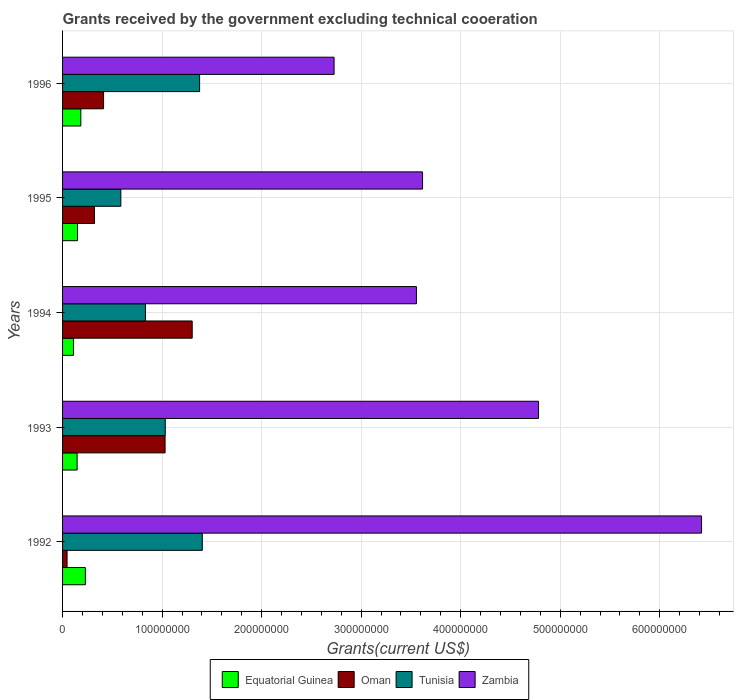Are the number of bars per tick equal to the number of legend labels?
Your answer should be compact. Yes. How many bars are there on the 4th tick from the top?
Offer a very short reply. 4. In how many cases, is the number of bars for a given year not equal to the number of legend labels?
Ensure brevity in your answer.  0. What is the total grants received by the government in Tunisia in 1992?
Your answer should be compact. 1.40e+08. Across all years, what is the maximum total grants received by the government in Oman?
Your answer should be very brief. 1.30e+08. Across all years, what is the minimum total grants received by the government in Tunisia?
Your response must be concise. 5.85e+07. What is the total total grants received by the government in Oman in the graph?
Provide a short and direct response. 3.11e+08. What is the difference between the total grants received by the government in Oman in 1992 and that in 1993?
Your response must be concise. -9.85e+07. What is the difference between the total grants received by the government in Oman in 1992 and the total grants received by the government in Zambia in 1996?
Give a very brief answer. -2.68e+08. What is the average total grants received by the government in Tunisia per year?
Give a very brief answer. 1.05e+08. In the year 1992, what is the difference between the total grants received by the government in Oman and total grants received by the government in Tunisia?
Ensure brevity in your answer.  -1.36e+08. What is the ratio of the total grants received by the government in Equatorial Guinea in 1992 to that in 1993?
Ensure brevity in your answer.  1.57. Is the difference between the total grants received by the government in Oman in 1994 and 1996 greater than the difference between the total grants received by the government in Tunisia in 1994 and 1996?
Make the answer very short. Yes. What is the difference between the highest and the second highest total grants received by the government in Tunisia?
Provide a short and direct response. 2.72e+06. What is the difference between the highest and the lowest total grants received by the government in Equatorial Guinea?
Provide a succinct answer. 1.20e+07. Is it the case that in every year, the sum of the total grants received by the government in Oman and total grants received by the government in Equatorial Guinea is greater than the sum of total grants received by the government in Tunisia and total grants received by the government in Zambia?
Keep it short and to the point. No. What does the 3rd bar from the top in 1995 represents?
Give a very brief answer. Oman. What does the 4th bar from the bottom in 1996 represents?
Offer a terse response. Zambia. How many years are there in the graph?
Keep it short and to the point. 5. Does the graph contain any zero values?
Provide a succinct answer. No. Does the graph contain grids?
Offer a very short reply. Yes. Where does the legend appear in the graph?
Your response must be concise. Bottom center. What is the title of the graph?
Give a very brief answer. Grants received by the government excluding technical cooeration. What is the label or title of the X-axis?
Give a very brief answer. Grants(current US$). What is the label or title of the Y-axis?
Make the answer very short. Years. What is the Grants(current US$) in Equatorial Guinea in 1992?
Make the answer very short. 2.29e+07. What is the Grants(current US$) of Oman in 1992?
Keep it short and to the point. 4.52e+06. What is the Grants(current US$) of Tunisia in 1992?
Your answer should be compact. 1.40e+08. What is the Grants(current US$) of Zambia in 1992?
Provide a short and direct response. 6.42e+08. What is the Grants(current US$) of Equatorial Guinea in 1993?
Make the answer very short. 1.46e+07. What is the Grants(current US$) in Oman in 1993?
Ensure brevity in your answer.  1.03e+08. What is the Grants(current US$) in Tunisia in 1993?
Give a very brief answer. 1.03e+08. What is the Grants(current US$) of Zambia in 1993?
Your response must be concise. 4.78e+08. What is the Grants(current US$) in Equatorial Guinea in 1994?
Your answer should be compact. 1.10e+07. What is the Grants(current US$) in Oman in 1994?
Give a very brief answer. 1.30e+08. What is the Grants(current US$) in Tunisia in 1994?
Your answer should be compact. 8.32e+07. What is the Grants(current US$) of Zambia in 1994?
Offer a very short reply. 3.56e+08. What is the Grants(current US$) in Equatorial Guinea in 1995?
Provide a succinct answer. 1.50e+07. What is the Grants(current US$) of Oman in 1995?
Your answer should be compact. 3.20e+07. What is the Grants(current US$) of Tunisia in 1995?
Your response must be concise. 5.85e+07. What is the Grants(current US$) of Zambia in 1995?
Your answer should be very brief. 3.62e+08. What is the Grants(current US$) of Equatorial Guinea in 1996?
Your response must be concise. 1.84e+07. What is the Grants(current US$) of Oman in 1996?
Give a very brief answer. 4.12e+07. What is the Grants(current US$) in Tunisia in 1996?
Provide a short and direct response. 1.38e+08. What is the Grants(current US$) in Zambia in 1996?
Keep it short and to the point. 2.73e+08. Across all years, what is the maximum Grants(current US$) in Equatorial Guinea?
Ensure brevity in your answer.  2.29e+07. Across all years, what is the maximum Grants(current US$) of Oman?
Your response must be concise. 1.30e+08. Across all years, what is the maximum Grants(current US$) in Tunisia?
Provide a short and direct response. 1.40e+08. Across all years, what is the maximum Grants(current US$) of Zambia?
Your response must be concise. 6.42e+08. Across all years, what is the minimum Grants(current US$) of Equatorial Guinea?
Provide a short and direct response. 1.10e+07. Across all years, what is the minimum Grants(current US$) in Oman?
Ensure brevity in your answer.  4.52e+06. Across all years, what is the minimum Grants(current US$) in Tunisia?
Ensure brevity in your answer.  5.85e+07. Across all years, what is the minimum Grants(current US$) of Zambia?
Your response must be concise. 2.73e+08. What is the total Grants(current US$) of Equatorial Guinea in the graph?
Ensure brevity in your answer.  8.18e+07. What is the total Grants(current US$) in Oman in the graph?
Your answer should be compact. 3.11e+08. What is the total Grants(current US$) in Tunisia in the graph?
Keep it short and to the point. 5.23e+08. What is the total Grants(current US$) of Zambia in the graph?
Ensure brevity in your answer.  2.11e+09. What is the difference between the Grants(current US$) in Equatorial Guinea in 1992 and that in 1993?
Offer a terse response. 8.30e+06. What is the difference between the Grants(current US$) of Oman in 1992 and that in 1993?
Offer a terse response. -9.85e+07. What is the difference between the Grants(current US$) in Tunisia in 1992 and that in 1993?
Offer a very short reply. 3.72e+07. What is the difference between the Grants(current US$) of Zambia in 1992 and that in 1993?
Provide a succinct answer. 1.64e+08. What is the difference between the Grants(current US$) in Equatorial Guinea in 1992 and that in 1994?
Make the answer very short. 1.20e+07. What is the difference between the Grants(current US$) of Oman in 1992 and that in 1994?
Make the answer very short. -1.26e+08. What is the difference between the Grants(current US$) in Tunisia in 1992 and that in 1994?
Ensure brevity in your answer.  5.72e+07. What is the difference between the Grants(current US$) of Zambia in 1992 and that in 1994?
Offer a terse response. 2.86e+08. What is the difference between the Grants(current US$) in Equatorial Guinea in 1992 and that in 1995?
Provide a short and direct response. 7.91e+06. What is the difference between the Grants(current US$) of Oman in 1992 and that in 1995?
Keep it short and to the point. -2.75e+07. What is the difference between the Grants(current US$) in Tunisia in 1992 and that in 1995?
Your response must be concise. 8.19e+07. What is the difference between the Grants(current US$) of Zambia in 1992 and that in 1995?
Make the answer very short. 2.80e+08. What is the difference between the Grants(current US$) of Equatorial Guinea in 1992 and that in 1996?
Make the answer very short. 4.56e+06. What is the difference between the Grants(current US$) in Oman in 1992 and that in 1996?
Keep it short and to the point. -3.67e+07. What is the difference between the Grants(current US$) of Tunisia in 1992 and that in 1996?
Your response must be concise. 2.72e+06. What is the difference between the Grants(current US$) in Zambia in 1992 and that in 1996?
Provide a short and direct response. 3.69e+08. What is the difference between the Grants(current US$) in Equatorial Guinea in 1993 and that in 1994?
Offer a terse response. 3.65e+06. What is the difference between the Grants(current US$) in Oman in 1993 and that in 1994?
Offer a very short reply. -2.72e+07. What is the difference between the Grants(current US$) in Tunisia in 1993 and that in 1994?
Offer a very short reply. 1.99e+07. What is the difference between the Grants(current US$) in Zambia in 1993 and that in 1994?
Make the answer very short. 1.23e+08. What is the difference between the Grants(current US$) of Equatorial Guinea in 1993 and that in 1995?
Your answer should be very brief. -3.90e+05. What is the difference between the Grants(current US$) in Oman in 1993 and that in 1995?
Offer a very short reply. 7.10e+07. What is the difference between the Grants(current US$) of Tunisia in 1993 and that in 1995?
Make the answer very short. 4.47e+07. What is the difference between the Grants(current US$) in Zambia in 1993 and that in 1995?
Make the answer very short. 1.17e+08. What is the difference between the Grants(current US$) of Equatorial Guinea in 1993 and that in 1996?
Offer a very short reply. -3.74e+06. What is the difference between the Grants(current US$) in Oman in 1993 and that in 1996?
Make the answer very short. 6.18e+07. What is the difference between the Grants(current US$) in Tunisia in 1993 and that in 1996?
Give a very brief answer. -3.45e+07. What is the difference between the Grants(current US$) in Zambia in 1993 and that in 1996?
Your answer should be very brief. 2.05e+08. What is the difference between the Grants(current US$) of Equatorial Guinea in 1994 and that in 1995?
Your answer should be compact. -4.04e+06. What is the difference between the Grants(current US$) in Oman in 1994 and that in 1995?
Your response must be concise. 9.82e+07. What is the difference between the Grants(current US$) in Tunisia in 1994 and that in 1995?
Offer a very short reply. 2.47e+07. What is the difference between the Grants(current US$) of Zambia in 1994 and that in 1995?
Your response must be concise. -6.15e+06. What is the difference between the Grants(current US$) in Equatorial Guinea in 1994 and that in 1996?
Your answer should be very brief. -7.39e+06. What is the difference between the Grants(current US$) in Oman in 1994 and that in 1996?
Keep it short and to the point. 8.90e+07. What is the difference between the Grants(current US$) of Tunisia in 1994 and that in 1996?
Your answer should be very brief. -5.44e+07. What is the difference between the Grants(current US$) in Zambia in 1994 and that in 1996?
Your response must be concise. 8.27e+07. What is the difference between the Grants(current US$) of Equatorial Guinea in 1995 and that in 1996?
Provide a succinct answer. -3.35e+06. What is the difference between the Grants(current US$) of Oman in 1995 and that in 1996?
Your answer should be compact. -9.16e+06. What is the difference between the Grants(current US$) of Tunisia in 1995 and that in 1996?
Give a very brief answer. -7.92e+07. What is the difference between the Grants(current US$) of Zambia in 1995 and that in 1996?
Offer a terse response. 8.89e+07. What is the difference between the Grants(current US$) of Equatorial Guinea in 1992 and the Grants(current US$) of Oman in 1993?
Your answer should be very brief. -8.01e+07. What is the difference between the Grants(current US$) of Equatorial Guinea in 1992 and the Grants(current US$) of Tunisia in 1993?
Your answer should be compact. -8.03e+07. What is the difference between the Grants(current US$) in Equatorial Guinea in 1992 and the Grants(current US$) in Zambia in 1993?
Give a very brief answer. -4.55e+08. What is the difference between the Grants(current US$) of Oman in 1992 and the Grants(current US$) of Tunisia in 1993?
Provide a succinct answer. -9.87e+07. What is the difference between the Grants(current US$) in Oman in 1992 and the Grants(current US$) in Zambia in 1993?
Your response must be concise. -4.74e+08. What is the difference between the Grants(current US$) in Tunisia in 1992 and the Grants(current US$) in Zambia in 1993?
Your answer should be compact. -3.38e+08. What is the difference between the Grants(current US$) of Equatorial Guinea in 1992 and the Grants(current US$) of Oman in 1994?
Your answer should be very brief. -1.07e+08. What is the difference between the Grants(current US$) in Equatorial Guinea in 1992 and the Grants(current US$) in Tunisia in 1994?
Provide a short and direct response. -6.03e+07. What is the difference between the Grants(current US$) of Equatorial Guinea in 1992 and the Grants(current US$) of Zambia in 1994?
Offer a terse response. -3.33e+08. What is the difference between the Grants(current US$) in Oman in 1992 and the Grants(current US$) in Tunisia in 1994?
Make the answer very short. -7.87e+07. What is the difference between the Grants(current US$) in Oman in 1992 and the Grants(current US$) in Zambia in 1994?
Give a very brief answer. -3.51e+08. What is the difference between the Grants(current US$) in Tunisia in 1992 and the Grants(current US$) in Zambia in 1994?
Offer a terse response. -2.15e+08. What is the difference between the Grants(current US$) in Equatorial Guinea in 1992 and the Grants(current US$) in Oman in 1995?
Provide a short and direct response. -9.12e+06. What is the difference between the Grants(current US$) in Equatorial Guinea in 1992 and the Grants(current US$) in Tunisia in 1995?
Keep it short and to the point. -3.56e+07. What is the difference between the Grants(current US$) in Equatorial Guinea in 1992 and the Grants(current US$) in Zambia in 1995?
Give a very brief answer. -3.39e+08. What is the difference between the Grants(current US$) in Oman in 1992 and the Grants(current US$) in Tunisia in 1995?
Offer a very short reply. -5.40e+07. What is the difference between the Grants(current US$) in Oman in 1992 and the Grants(current US$) in Zambia in 1995?
Provide a succinct answer. -3.57e+08. What is the difference between the Grants(current US$) in Tunisia in 1992 and the Grants(current US$) in Zambia in 1995?
Your answer should be compact. -2.21e+08. What is the difference between the Grants(current US$) of Equatorial Guinea in 1992 and the Grants(current US$) of Oman in 1996?
Ensure brevity in your answer.  -1.83e+07. What is the difference between the Grants(current US$) in Equatorial Guinea in 1992 and the Grants(current US$) in Tunisia in 1996?
Provide a succinct answer. -1.15e+08. What is the difference between the Grants(current US$) in Equatorial Guinea in 1992 and the Grants(current US$) in Zambia in 1996?
Your response must be concise. -2.50e+08. What is the difference between the Grants(current US$) of Oman in 1992 and the Grants(current US$) of Tunisia in 1996?
Make the answer very short. -1.33e+08. What is the difference between the Grants(current US$) of Oman in 1992 and the Grants(current US$) of Zambia in 1996?
Make the answer very short. -2.68e+08. What is the difference between the Grants(current US$) in Tunisia in 1992 and the Grants(current US$) in Zambia in 1996?
Give a very brief answer. -1.32e+08. What is the difference between the Grants(current US$) of Equatorial Guinea in 1993 and the Grants(current US$) of Oman in 1994?
Your answer should be very brief. -1.16e+08. What is the difference between the Grants(current US$) of Equatorial Guinea in 1993 and the Grants(current US$) of Tunisia in 1994?
Keep it short and to the point. -6.86e+07. What is the difference between the Grants(current US$) of Equatorial Guinea in 1993 and the Grants(current US$) of Zambia in 1994?
Give a very brief answer. -3.41e+08. What is the difference between the Grants(current US$) of Oman in 1993 and the Grants(current US$) of Tunisia in 1994?
Your response must be concise. 1.97e+07. What is the difference between the Grants(current US$) of Oman in 1993 and the Grants(current US$) of Zambia in 1994?
Your response must be concise. -2.53e+08. What is the difference between the Grants(current US$) in Tunisia in 1993 and the Grants(current US$) in Zambia in 1994?
Provide a succinct answer. -2.52e+08. What is the difference between the Grants(current US$) of Equatorial Guinea in 1993 and the Grants(current US$) of Oman in 1995?
Make the answer very short. -1.74e+07. What is the difference between the Grants(current US$) of Equatorial Guinea in 1993 and the Grants(current US$) of Tunisia in 1995?
Ensure brevity in your answer.  -4.39e+07. What is the difference between the Grants(current US$) in Equatorial Guinea in 1993 and the Grants(current US$) in Zambia in 1995?
Offer a terse response. -3.47e+08. What is the difference between the Grants(current US$) of Oman in 1993 and the Grants(current US$) of Tunisia in 1995?
Your answer should be compact. 4.45e+07. What is the difference between the Grants(current US$) of Oman in 1993 and the Grants(current US$) of Zambia in 1995?
Offer a very short reply. -2.59e+08. What is the difference between the Grants(current US$) of Tunisia in 1993 and the Grants(current US$) of Zambia in 1995?
Keep it short and to the point. -2.58e+08. What is the difference between the Grants(current US$) of Equatorial Guinea in 1993 and the Grants(current US$) of Oman in 1996?
Your response must be concise. -2.66e+07. What is the difference between the Grants(current US$) of Equatorial Guinea in 1993 and the Grants(current US$) of Tunisia in 1996?
Offer a terse response. -1.23e+08. What is the difference between the Grants(current US$) in Equatorial Guinea in 1993 and the Grants(current US$) in Zambia in 1996?
Your response must be concise. -2.58e+08. What is the difference between the Grants(current US$) of Oman in 1993 and the Grants(current US$) of Tunisia in 1996?
Your answer should be very brief. -3.47e+07. What is the difference between the Grants(current US$) in Oman in 1993 and the Grants(current US$) in Zambia in 1996?
Keep it short and to the point. -1.70e+08. What is the difference between the Grants(current US$) of Tunisia in 1993 and the Grants(current US$) of Zambia in 1996?
Provide a short and direct response. -1.70e+08. What is the difference between the Grants(current US$) in Equatorial Guinea in 1994 and the Grants(current US$) in Oman in 1995?
Keep it short and to the point. -2.11e+07. What is the difference between the Grants(current US$) of Equatorial Guinea in 1994 and the Grants(current US$) of Tunisia in 1995?
Your answer should be very brief. -4.76e+07. What is the difference between the Grants(current US$) of Equatorial Guinea in 1994 and the Grants(current US$) of Zambia in 1995?
Offer a very short reply. -3.51e+08. What is the difference between the Grants(current US$) in Oman in 1994 and the Grants(current US$) in Tunisia in 1995?
Offer a terse response. 7.17e+07. What is the difference between the Grants(current US$) of Oman in 1994 and the Grants(current US$) of Zambia in 1995?
Your response must be concise. -2.31e+08. What is the difference between the Grants(current US$) of Tunisia in 1994 and the Grants(current US$) of Zambia in 1995?
Your answer should be very brief. -2.78e+08. What is the difference between the Grants(current US$) in Equatorial Guinea in 1994 and the Grants(current US$) in Oman in 1996?
Offer a terse response. -3.02e+07. What is the difference between the Grants(current US$) in Equatorial Guinea in 1994 and the Grants(current US$) in Tunisia in 1996?
Offer a very short reply. -1.27e+08. What is the difference between the Grants(current US$) of Equatorial Guinea in 1994 and the Grants(current US$) of Zambia in 1996?
Ensure brevity in your answer.  -2.62e+08. What is the difference between the Grants(current US$) in Oman in 1994 and the Grants(current US$) in Tunisia in 1996?
Make the answer very short. -7.44e+06. What is the difference between the Grants(current US$) in Oman in 1994 and the Grants(current US$) in Zambia in 1996?
Make the answer very short. -1.43e+08. What is the difference between the Grants(current US$) of Tunisia in 1994 and the Grants(current US$) of Zambia in 1996?
Your response must be concise. -1.90e+08. What is the difference between the Grants(current US$) in Equatorial Guinea in 1995 and the Grants(current US$) in Oman in 1996?
Provide a succinct answer. -2.62e+07. What is the difference between the Grants(current US$) in Equatorial Guinea in 1995 and the Grants(current US$) in Tunisia in 1996?
Provide a short and direct response. -1.23e+08. What is the difference between the Grants(current US$) in Equatorial Guinea in 1995 and the Grants(current US$) in Zambia in 1996?
Offer a terse response. -2.58e+08. What is the difference between the Grants(current US$) of Oman in 1995 and the Grants(current US$) of Tunisia in 1996?
Your answer should be very brief. -1.06e+08. What is the difference between the Grants(current US$) in Oman in 1995 and the Grants(current US$) in Zambia in 1996?
Your response must be concise. -2.41e+08. What is the difference between the Grants(current US$) of Tunisia in 1995 and the Grants(current US$) of Zambia in 1996?
Provide a succinct answer. -2.14e+08. What is the average Grants(current US$) of Equatorial Guinea per year?
Your answer should be compact. 1.64e+07. What is the average Grants(current US$) of Oman per year?
Keep it short and to the point. 6.22e+07. What is the average Grants(current US$) in Tunisia per year?
Make the answer very short. 1.05e+08. What is the average Grants(current US$) in Zambia per year?
Provide a succinct answer. 4.22e+08. In the year 1992, what is the difference between the Grants(current US$) of Equatorial Guinea and Grants(current US$) of Oman?
Your response must be concise. 1.84e+07. In the year 1992, what is the difference between the Grants(current US$) of Equatorial Guinea and Grants(current US$) of Tunisia?
Offer a very short reply. -1.17e+08. In the year 1992, what is the difference between the Grants(current US$) in Equatorial Guinea and Grants(current US$) in Zambia?
Offer a terse response. -6.19e+08. In the year 1992, what is the difference between the Grants(current US$) in Oman and Grants(current US$) in Tunisia?
Your answer should be very brief. -1.36e+08. In the year 1992, what is the difference between the Grants(current US$) in Oman and Grants(current US$) in Zambia?
Make the answer very short. -6.37e+08. In the year 1992, what is the difference between the Grants(current US$) in Tunisia and Grants(current US$) in Zambia?
Offer a very short reply. -5.02e+08. In the year 1993, what is the difference between the Grants(current US$) in Equatorial Guinea and Grants(current US$) in Oman?
Your answer should be very brief. -8.84e+07. In the year 1993, what is the difference between the Grants(current US$) in Equatorial Guinea and Grants(current US$) in Tunisia?
Offer a very short reply. -8.86e+07. In the year 1993, what is the difference between the Grants(current US$) of Equatorial Guinea and Grants(current US$) of Zambia?
Provide a succinct answer. -4.64e+08. In the year 1993, what is the difference between the Grants(current US$) of Oman and Grants(current US$) of Zambia?
Offer a terse response. -3.75e+08. In the year 1993, what is the difference between the Grants(current US$) in Tunisia and Grants(current US$) in Zambia?
Your response must be concise. -3.75e+08. In the year 1994, what is the difference between the Grants(current US$) of Equatorial Guinea and Grants(current US$) of Oman?
Keep it short and to the point. -1.19e+08. In the year 1994, what is the difference between the Grants(current US$) in Equatorial Guinea and Grants(current US$) in Tunisia?
Offer a terse response. -7.23e+07. In the year 1994, what is the difference between the Grants(current US$) in Equatorial Guinea and Grants(current US$) in Zambia?
Give a very brief answer. -3.45e+08. In the year 1994, what is the difference between the Grants(current US$) of Oman and Grants(current US$) of Tunisia?
Your answer should be very brief. 4.70e+07. In the year 1994, what is the difference between the Grants(current US$) in Oman and Grants(current US$) in Zambia?
Offer a terse response. -2.25e+08. In the year 1994, what is the difference between the Grants(current US$) of Tunisia and Grants(current US$) of Zambia?
Your answer should be very brief. -2.72e+08. In the year 1995, what is the difference between the Grants(current US$) of Equatorial Guinea and Grants(current US$) of Oman?
Offer a very short reply. -1.70e+07. In the year 1995, what is the difference between the Grants(current US$) in Equatorial Guinea and Grants(current US$) in Tunisia?
Keep it short and to the point. -4.35e+07. In the year 1995, what is the difference between the Grants(current US$) in Equatorial Guinea and Grants(current US$) in Zambia?
Provide a succinct answer. -3.47e+08. In the year 1995, what is the difference between the Grants(current US$) in Oman and Grants(current US$) in Tunisia?
Offer a terse response. -2.65e+07. In the year 1995, what is the difference between the Grants(current US$) of Oman and Grants(current US$) of Zambia?
Give a very brief answer. -3.30e+08. In the year 1995, what is the difference between the Grants(current US$) of Tunisia and Grants(current US$) of Zambia?
Your answer should be compact. -3.03e+08. In the year 1996, what is the difference between the Grants(current US$) in Equatorial Guinea and Grants(current US$) in Oman?
Offer a very short reply. -2.28e+07. In the year 1996, what is the difference between the Grants(current US$) in Equatorial Guinea and Grants(current US$) in Tunisia?
Provide a succinct answer. -1.19e+08. In the year 1996, what is the difference between the Grants(current US$) in Equatorial Guinea and Grants(current US$) in Zambia?
Your answer should be very brief. -2.54e+08. In the year 1996, what is the difference between the Grants(current US$) of Oman and Grants(current US$) of Tunisia?
Offer a very short reply. -9.65e+07. In the year 1996, what is the difference between the Grants(current US$) in Oman and Grants(current US$) in Zambia?
Your answer should be compact. -2.32e+08. In the year 1996, what is the difference between the Grants(current US$) in Tunisia and Grants(current US$) in Zambia?
Offer a very short reply. -1.35e+08. What is the ratio of the Grants(current US$) in Equatorial Guinea in 1992 to that in 1993?
Your answer should be compact. 1.57. What is the ratio of the Grants(current US$) in Oman in 1992 to that in 1993?
Offer a very short reply. 0.04. What is the ratio of the Grants(current US$) of Tunisia in 1992 to that in 1993?
Make the answer very short. 1.36. What is the ratio of the Grants(current US$) in Zambia in 1992 to that in 1993?
Keep it short and to the point. 1.34. What is the ratio of the Grants(current US$) in Equatorial Guinea in 1992 to that in 1994?
Offer a terse response. 2.09. What is the ratio of the Grants(current US$) of Oman in 1992 to that in 1994?
Provide a succinct answer. 0.03. What is the ratio of the Grants(current US$) in Tunisia in 1992 to that in 1994?
Your answer should be very brief. 1.69. What is the ratio of the Grants(current US$) in Zambia in 1992 to that in 1994?
Offer a very short reply. 1.81. What is the ratio of the Grants(current US$) of Equatorial Guinea in 1992 to that in 1995?
Offer a terse response. 1.53. What is the ratio of the Grants(current US$) in Oman in 1992 to that in 1995?
Offer a very short reply. 0.14. What is the ratio of the Grants(current US$) of Tunisia in 1992 to that in 1995?
Make the answer very short. 2.4. What is the ratio of the Grants(current US$) in Zambia in 1992 to that in 1995?
Keep it short and to the point. 1.77. What is the ratio of the Grants(current US$) of Equatorial Guinea in 1992 to that in 1996?
Your answer should be compact. 1.25. What is the ratio of the Grants(current US$) of Oman in 1992 to that in 1996?
Your answer should be compact. 0.11. What is the ratio of the Grants(current US$) of Tunisia in 1992 to that in 1996?
Provide a succinct answer. 1.02. What is the ratio of the Grants(current US$) of Zambia in 1992 to that in 1996?
Your answer should be very brief. 2.35. What is the ratio of the Grants(current US$) of Equatorial Guinea in 1993 to that in 1994?
Provide a succinct answer. 1.33. What is the ratio of the Grants(current US$) in Oman in 1993 to that in 1994?
Make the answer very short. 0.79. What is the ratio of the Grants(current US$) of Tunisia in 1993 to that in 1994?
Provide a short and direct response. 1.24. What is the ratio of the Grants(current US$) in Zambia in 1993 to that in 1994?
Ensure brevity in your answer.  1.35. What is the ratio of the Grants(current US$) of Oman in 1993 to that in 1995?
Provide a short and direct response. 3.22. What is the ratio of the Grants(current US$) of Tunisia in 1993 to that in 1995?
Provide a short and direct response. 1.76. What is the ratio of the Grants(current US$) of Zambia in 1993 to that in 1995?
Offer a terse response. 1.32. What is the ratio of the Grants(current US$) of Equatorial Guinea in 1993 to that in 1996?
Offer a very short reply. 0.8. What is the ratio of the Grants(current US$) in Oman in 1993 to that in 1996?
Offer a very short reply. 2.5. What is the ratio of the Grants(current US$) in Tunisia in 1993 to that in 1996?
Provide a succinct answer. 0.75. What is the ratio of the Grants(current US$) in Zambia in 1993 to that in 1996?
Offer a terse response. 1.75. What is the ratio of the Grants(current US$) in Equatorial Guinea in 1994 to that in 1995?
Ensure brevity in your answer.  0.73. What is the ratio of the Grants(current US$) in Oman in 1994 to that in 1995?
Provide a succinct answer. 4.07. What is the ratio of the Grants(current US$) of Tunisia in 1994 to that in 1995?
Your answer should be compact. 1.42. What is the ratio of the Grants(current US$) of Zambia in 1994 to that in 1995?
Offer a terse response. 0.98. What is the ratio of the Grants(current US$) of Equatorial Guinea in 1994 to that in 1996?
Give a very brief answer. 0.6. What is the ratio of the Grants(current US$) in Oman in 1994 to that in 1996?
Make the answer very short. 3.16. What is the ratio of the Grants(current US$) of Tunisia in 1994 to that in 1996?
Provide a succinct answer. 0.6. What is the ratio of the Grants(current US$) of Zambia in 1994 to that in 1996?
Make the answer very short. 1.3. What is the ratio of the Grants(current US$) of Equatorial Guinea in 1995 to that in 1996?
Your response must be concise. 0.82. What is the ratio of the Grants(current US$) of Oman in 1995 to that in 1996?
Your response must be concise. 0.78. What is the ratio of the Grants(current US$) in Tunisia in 1995 to that in 1996?
Provide a short and direct response. 0.43. What is the ratio of the Grants(current US$) of Zambia in 1995 to that in 1996?
Provide a short and direct response. 1.33. What is the difference between the highest and the second highest Grants(current US$) of Equatorial Guinea?
Offer a very short reply. 4.56e+06. What is the difference between the highest and the second highest Grants(current US$) in Oman?
Offer a terse response. 2.72e+07. What is the difference between the highest and the second highest Grants(current US$) of Tunisia?
Your response must be concise. 2.72e+06. What is the difference between the highest and the second highest Grants(current US$) of Zambia?
Give a very brief answer. 1.64e+08. What is the difference between the highest and the lowest Grants(current US$) of Equatorial Guinea?
Offer a very short reply. 1.20e+07. What is the difference between the highest and the lowest Grants(current US$) in Oman?
Offer a terse response. 1.26e+08. What is the difference between the highest and the lowest Grants(current US$) in Tunisia?
Your answer should be compact. 8.19e+07. What is the difference between the highest and the lowest Grants(current US$) in Zambia?
Your answer should be very brief. 3.69e+08. 